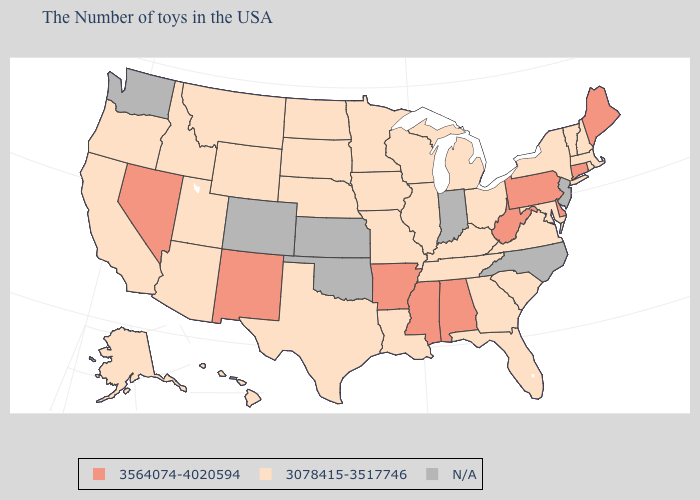What is the lowest value in states that border Nebraska?
Be succinct. 3078415-3517746. How many symbols are there in the legend?
Give a very brief answer. 3. What is the value of West Virginia?
Keep it brief. 3564074-4020594. What is the lowest value in the USA?
Quick response, please. 3078415-3517746. Name the states that have a value in the range 3564074-4020594?
Be succinct. Maine, Connecticut, Delaware, Pennsylvania, West Virginia, Alabama, Mississippi, Arkansas, New Mexico, Nevada. What is the highest value in the USA?
Be succinct. 3564074-4020594. Is the legend a continuous bar?
Be succinct. No. What is the value of Georgia?
Write a very short answer. 3078415-3517746. What is the highest value in the MidWest ?
Give a very brief answer. 3078415-3517746. Does the map have missing data?
Short answer required. Yes. Among the states that border Alabama , which have the lowest value?
Short answer required. Florida, Georgia, Tennessee. Does Nevada have the lowest value in the West?
Keep it brief. No. Name the states that have a value in the range N/A?
Keep it brief. New Jersey, North Carolina, Indiana, Kansas, Oklahoma, Colorado, Washington. 